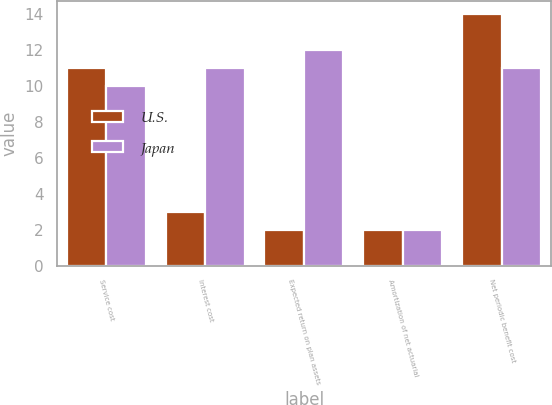<chart> <loc_0><loc_0><loc_500><loc_500><stacked_bar_chart><ecel><fcel>Service cost<fcel>Interest cost<fcel>Expected return on plan assets<fcel>Amortization of net actuarial<fcel>Net periodic benefit cost<nl><fcel>U.S.<fcel>11<fcel>3<fcel>2<fcel>2<fcel>14<nl><fcel>Japan<fcel>10<fcel>11<fcel>12<fcel>2<fcel>11<nl></chart> 